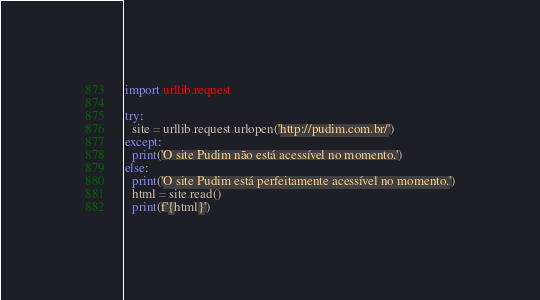Convert code to text. <code><loc_0><loc_0><loc_500><loc_500><_Python_>import urllib.request

try:
  site = urllib.request.urlopen('http://pudim.com.br/')
except:
  print('O site Pudim não está acessível no momento.')
else:
  print('O site Pudim está perfeitamente acessível no momento.')
  html = site.read()
  print(f'{html}')
</code> 